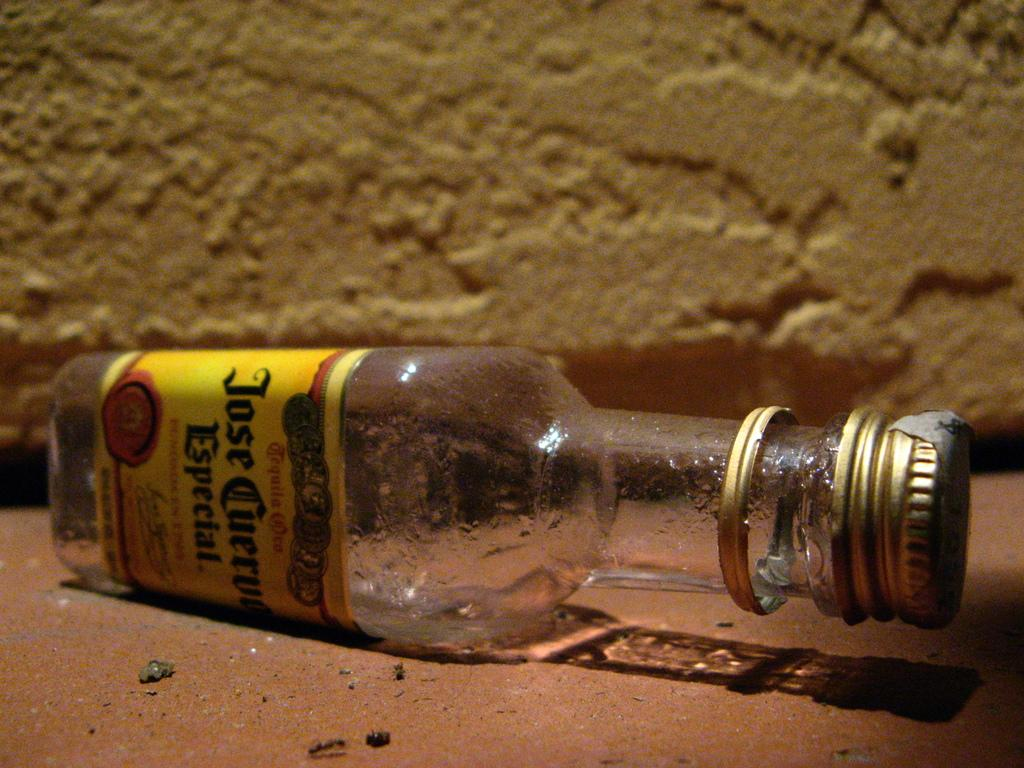<image>
Summarize the visual content of the image. An empty bottle of Jose Cuervo lies sideways on the ground. 